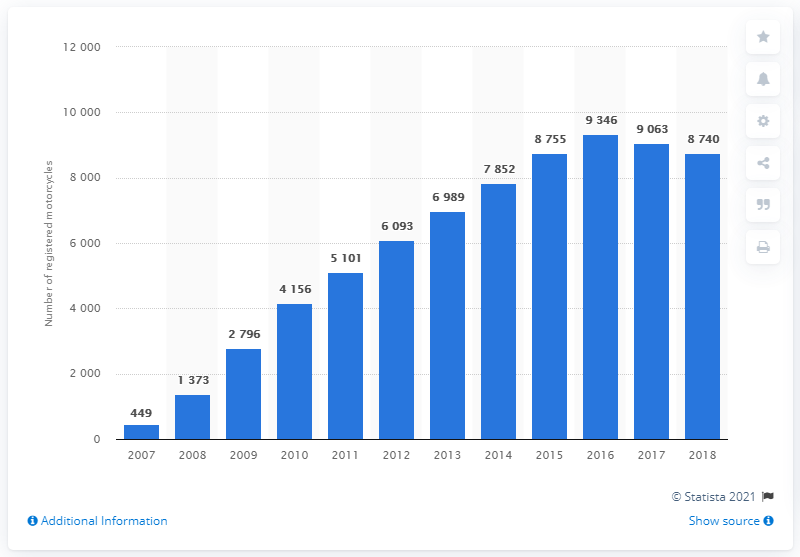Highlight a few significant elements in this photo. In 2018, there were 8,740 Triumph Street Triples sold in Great Britain. In 2007, the number of Triumph Street Triples sold in Great Britain was 449. 